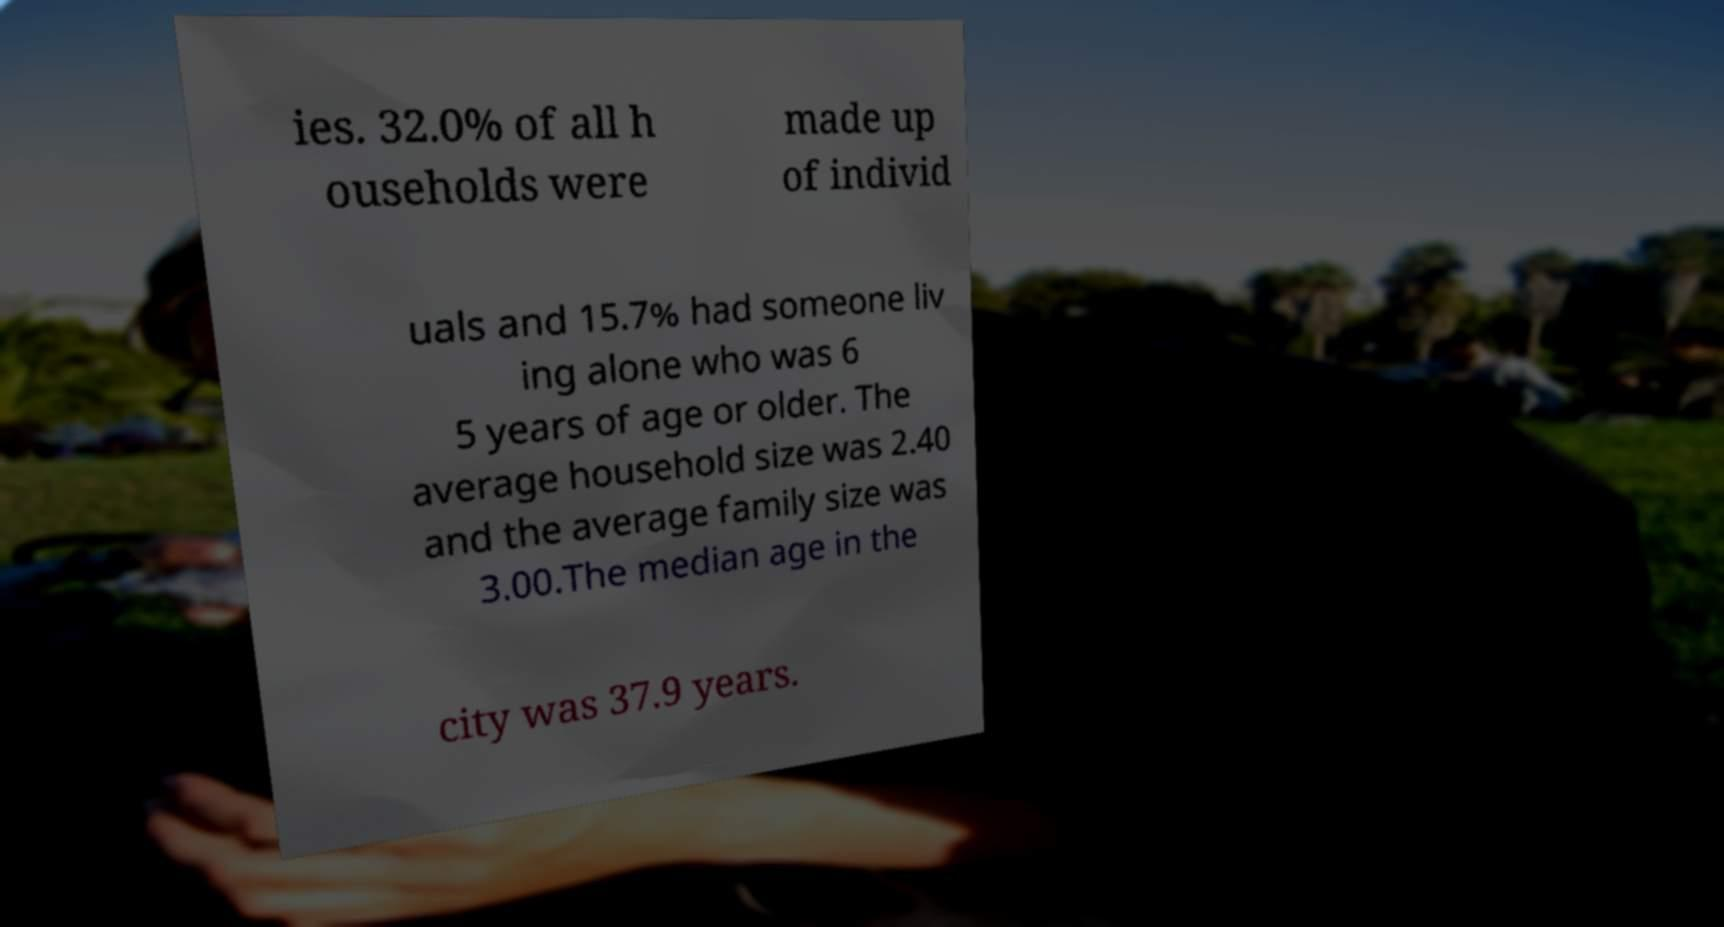Could you extract and type out the text from this image? ies. 32.0% of all h ouseholds were made up of individ uals and 15.7% had someone liv ing alone who was 6 5 years of age or older. The average household size was 2.40 and the average family size was 3.00.The median age in the city was 37.9 years. 